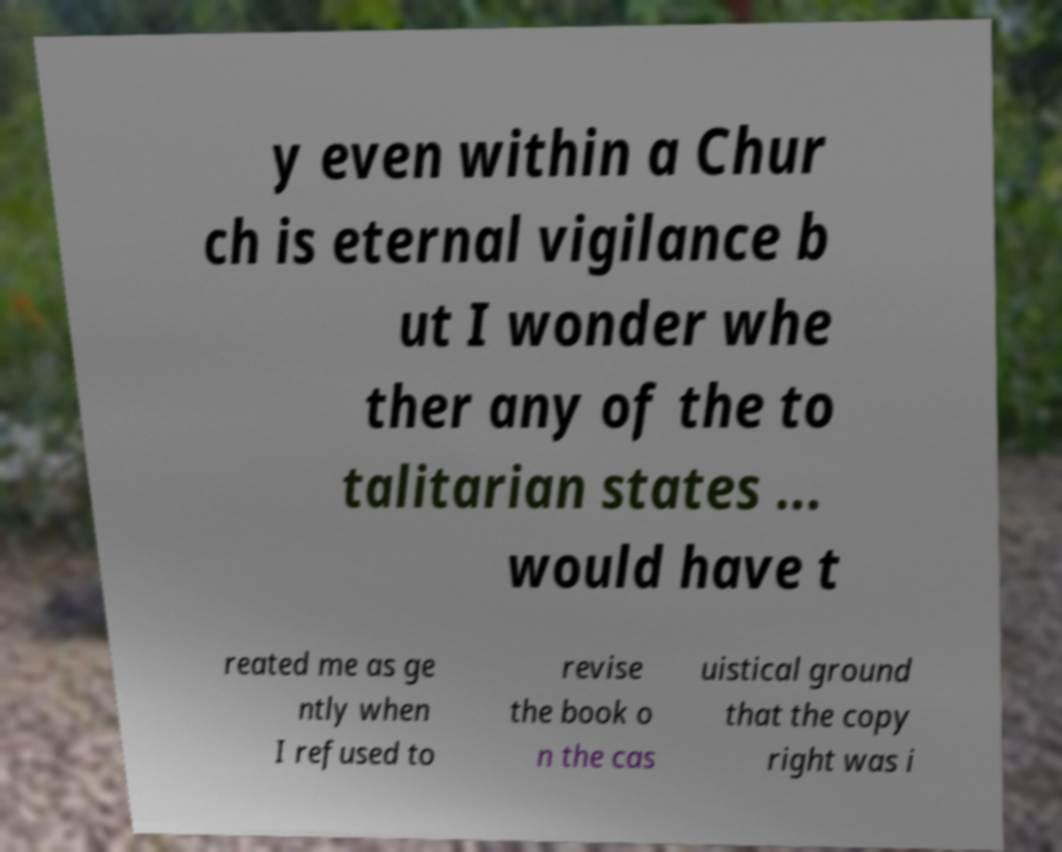Please identify and transcribe the text found in this image. y even within a Chur ch is eternal vigilance b ut I wonder whe ther any of the to talitarian states ... would have t reated me as ge ntly when I refused to revise the book o n the cas uistical ground that the copy right was i 